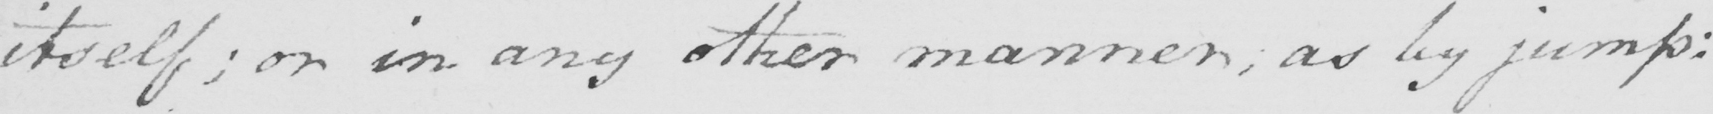What is written in this line of handwriting? itself ; or in any other manner ; as by jump : 